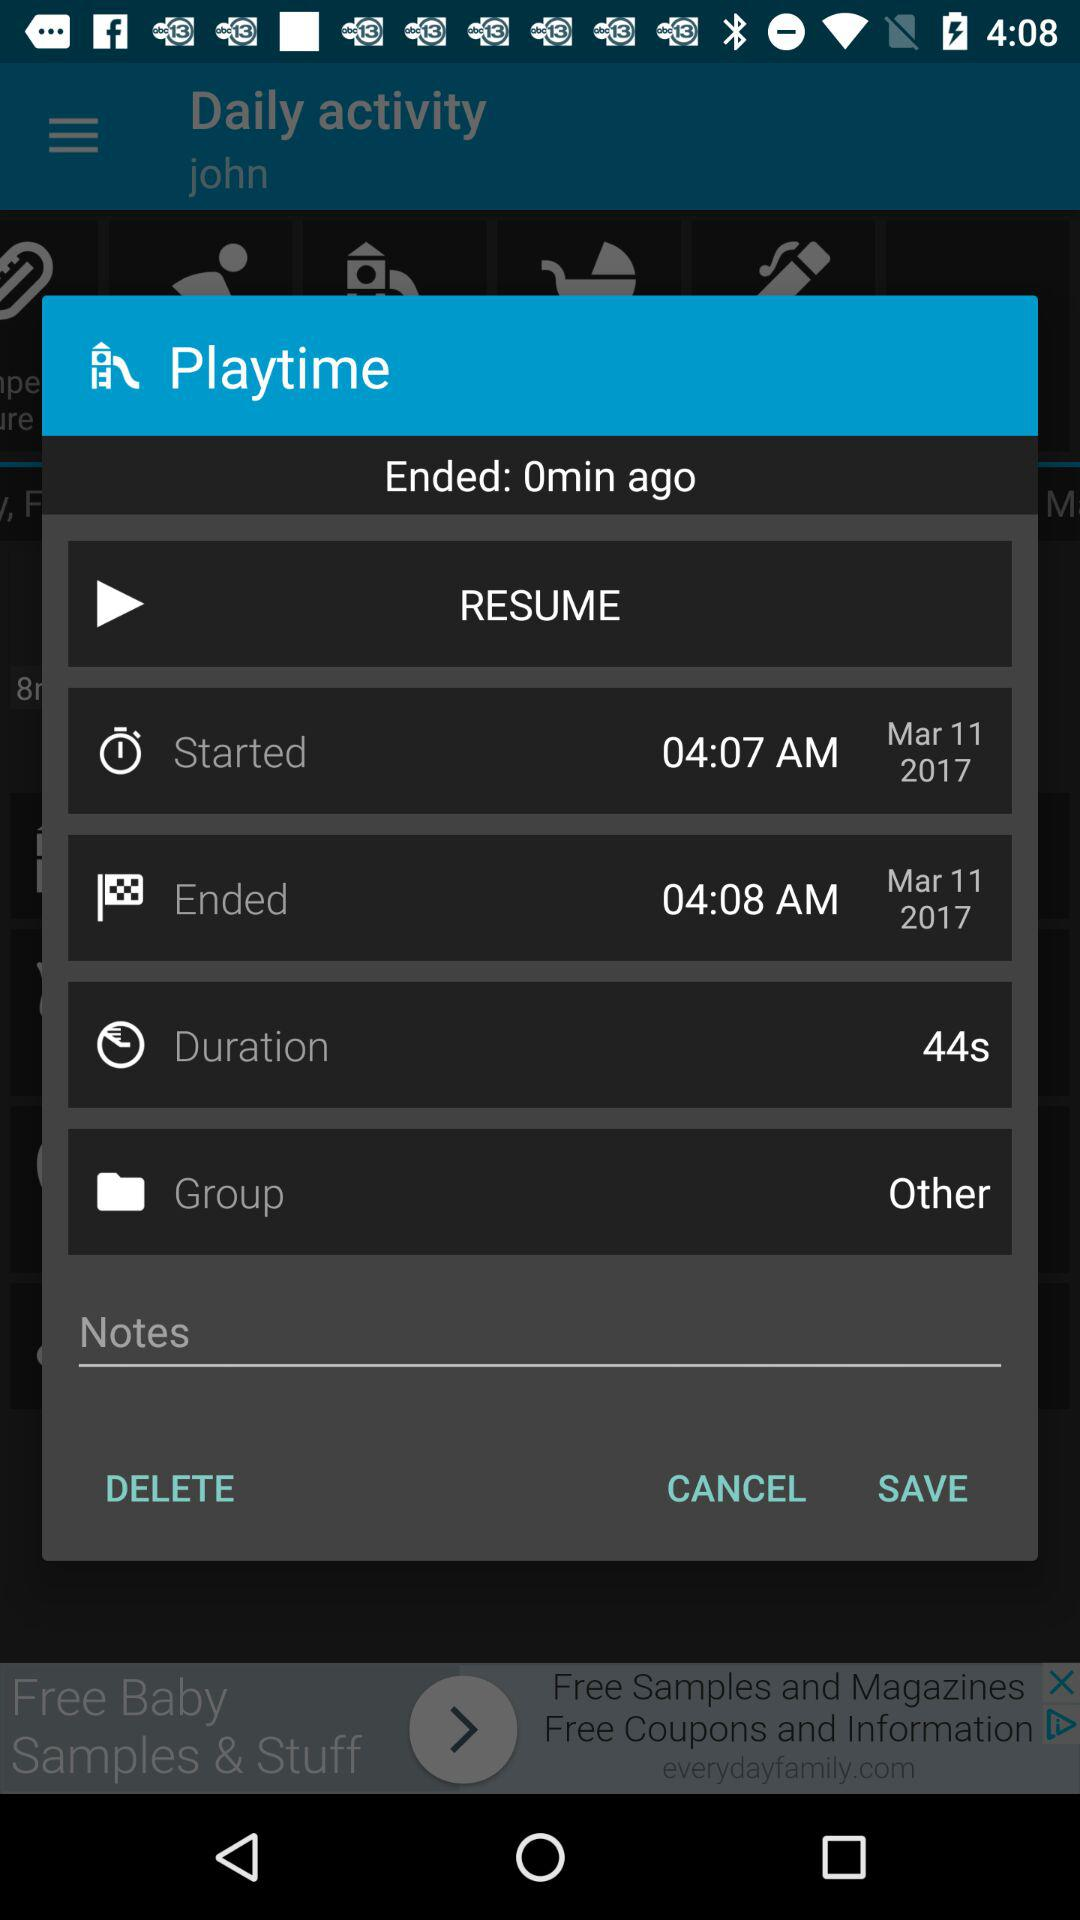What is the starting time? The starting time is 04:07 a.m. 